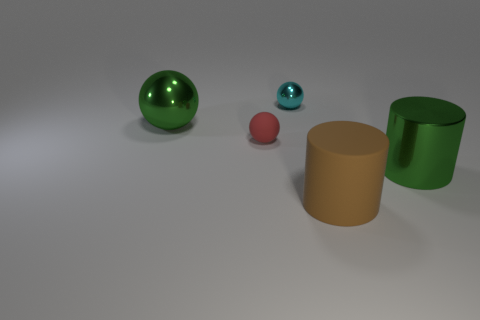Does the big ball have the same color as the metal thing that is in front of the red rubber sphere?
Provide a succinct answer. Yes. The tiny metal sphere is what color?
Your answer should be compact. Cyan. There is a large object that is in front of the large shiny cylinder; what material is it?
Your response must be concise. Rubber. What is the size of the green object that is the same shape as the big brown thing?
Offer a very short reply. Large. Are there fewer big green balls behind the small red matte object than large blue objects?
Ensure brevity in your answer.  No. Are any tiny green rubber cylinders visible?
Offer a terse response. No. The other large thing that is the same shape as the red matte thing is what color?
Ensure brevity in your answer.  Green. Is the color of the metal sphere behind the large green ball the same as the large metallic sphere?
Make the answer very short. No. Does the brown matte cylinder have the same size as the cyan sphere?
Ensure brevity in your answer.  No. There is a brown object that is the same material as the small red thing; what is its shape?
Keep it short and to the point. Cylinder. 